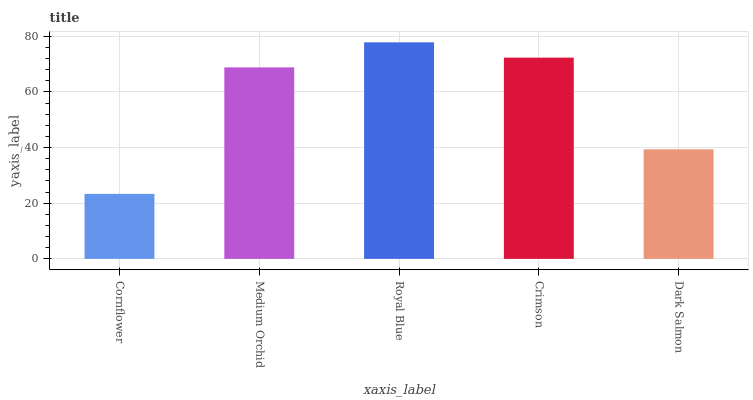Is Cornflower the minimum?
Answer yes or no. Yes. Is Royal Blue the maximum?
Answer yes or no. Yes. Is Medium Orchid the minimum?
Answer yes or no. No. Is Medium Orchid the maximum?
Answer yes or no. No. Is Medium Orchid greater than Cornflower?
Answer yes or no. Yes. Is Cornflower less than Medium Orchid?
Answer yes or no. Yes. Is Cornflower greater than Medium Orchid?
Answer yes or no. No. Is Medium Orchid less than Cornflower?
Answer yes or no. No. Is Medium Orchid the high median?
Answer yes or no. Yes. Is Medium Orchid the low median?
Answer yes or no. Yes. Is Cornflower the high median?
Answer yes or no. No. Is Dark Salmon the low median?
Answer yes or no. No. 